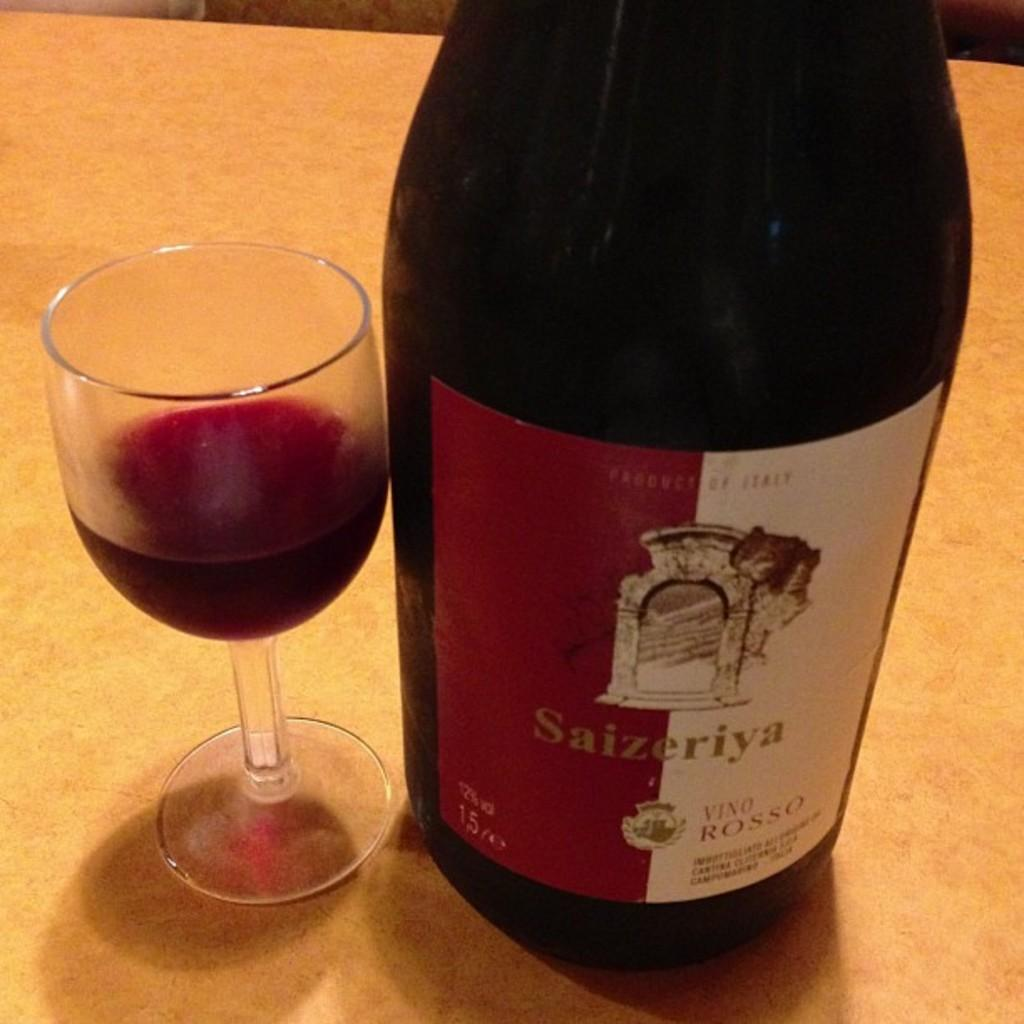What piece of furniture is present in the image? There is a table in the image. What is on the table? There is a glass with liquid on the table. Is there anything else related to the glass on the table? Yes, there is a bottle on the right side of the glass. What type of game is being played on the table in the image? There is no game being played on the table in the image; it only contains a glass with liquid and a bottle. Can you describe the secretary sitting next to the table in the image? There is no secretary present in the image; it only features a table, a glass with liquid, and a bottle. 